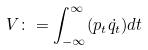Convert formula to latex. <formula><loc_0><loc_0><loc_500><loc_500>V \colon = \int ^ { \infty } _ { - \infty } ( p _ { t } \dot { q _ { t } } ) d t</formula> 